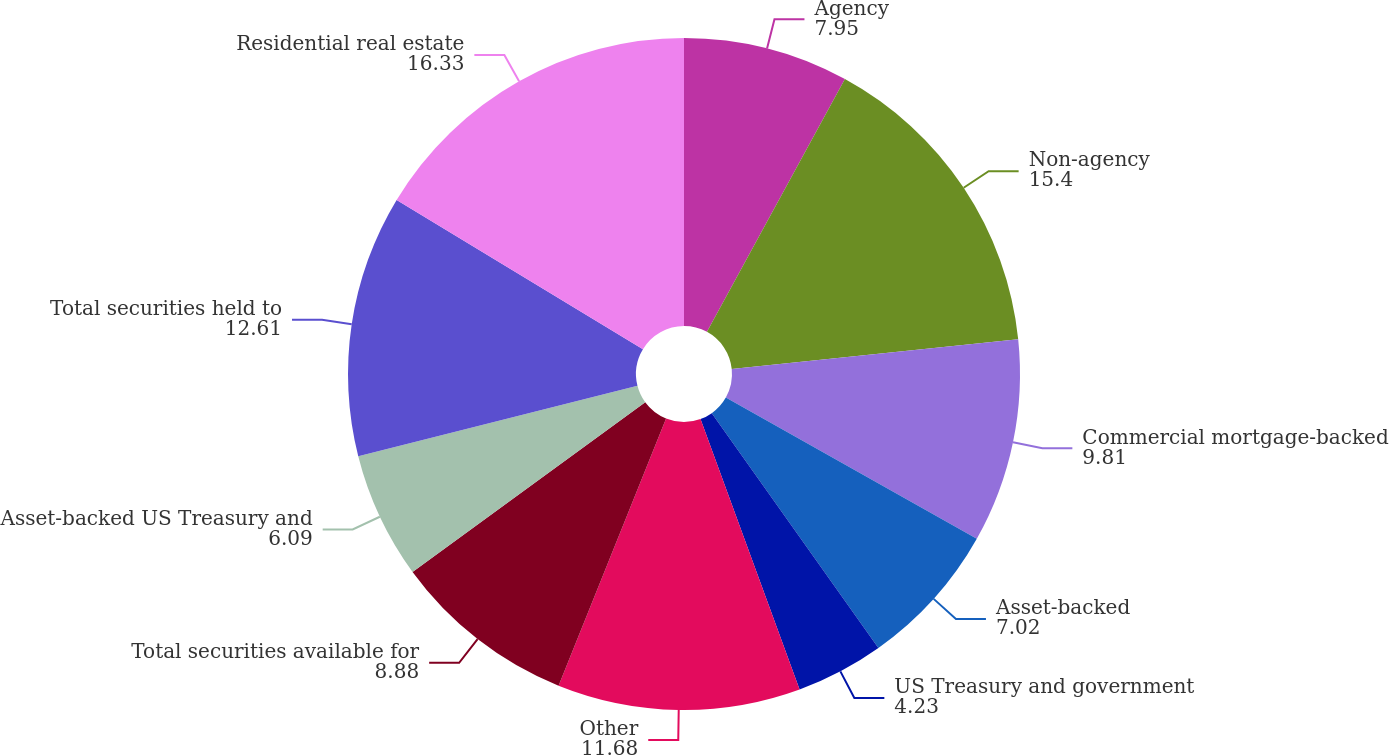Convert chart to OTSL. <chart><loc_0><loc_0><loc_500><loc_500><pie_chart><fcel>Agency<fcel>Non-agency<fcel>Commercial mortgage-backed<fcel>Asset-backed<fcel>US Treasury and government<fcel>Other<fcel>Total securities available for<fcel>Asset-backed US Treasury and<fcel>Total securities held to<fcel>Residential real estate<nl><fcel>7.95%<fcel>15.4%<fcel>9.81%<fcel>7.02%<fcel>4.23%<fcel>11.68%<fcel>8.88%<fcel>6.09%<fcel>12.61%<fcel>16.33%<nl></chart> 